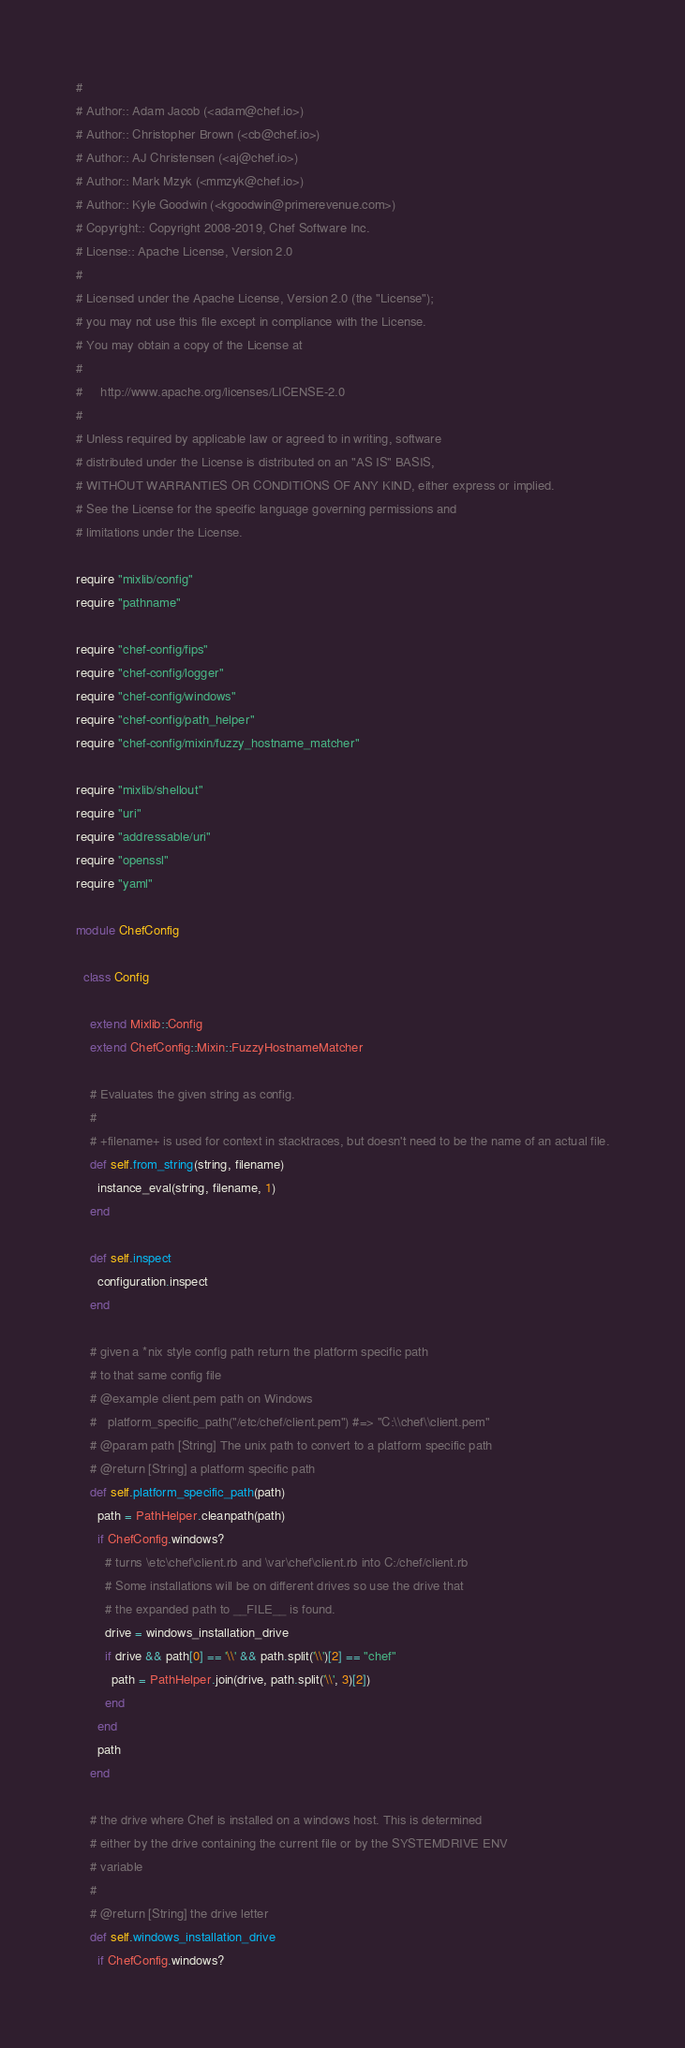Convert code to text. <code><loc_0><loc_0><loc_500><loc_500><_Ruby_>#
# Author:: Adam Jacob (<adam@chef.io>)
# Author:: Christopher Brown (<cb@chef.io>)
# Author:: AJ Christensen (<aj@chef.io>)
# Author:: Mark Mzyk (<mmzyk@chef.io>)
# Author:: Kyle Goodwin (<kgoodwin@primerevenue.com>)
# Copyright:: Copyright 2008-2019, Chef Software Inc.
# License:: Apache License, Version 2.0
#
# Licensed under the Apache License, Version 2.0 (the "License");
# you may not use this file except in compliance with the License.
# You may obtain a copy of the License at
#
#     http://www.apache.org/licenses/LICENSE-2.0
#
# Unless required by applicable law or agreed to in writing, software
# distributed under the License is distributed on an "AS IS" BASIS,
# WITHOUT WARRANTIES OR CONDITIONS OF ANY KIND, either express or implied.
# See the License for the specific language governing permissions and
# limitations under the License.

require "mixlib/config"
require "pathname"

require "chef-config/fips"
require "chef-config/logger"
require "chef-config/windows"
require "chef-config/path_helper"
require "chef-config/mixin/fuzzy_hostname_matcher"

require "mixlib/shellout"
require "uri"
require "addressable/uri"
require "openssl"
require "yaml"

module ChefConfig

  class Config

    extend Mixlib::Config
    extend ChefConfig::Mixin::FuzzyHostnameMatcher

    # Evaluates the given string as config.
    #
    # +filename+ is used for context in stacktraces, but doesn't need to be the name of an actual file.
    def self.from_string(string, filename)
      instance_eval(string, filename, 1)
    end

    def self.inspect
      configuration.inspect
    end

    # given a *nix style config path return the platform specific path
    # to that same config file
    # @example client.pem path on Windows
    #   platform_specific_path("/etc/chef/client.pem") #=> "C:\\chef\\client.pem"
    # @param path [String] The unix path to convert to a platform specific path
    # @return [String] a platform specific path
    def self.platform_specific_path(path)
      path = PathHelper.cleanpath(path)
      if ChefConfig.windows?
        # turns \etc\chef\client.rb and \var\chef\client.rb into C:/chef/client.rb
        # Some installations will be on different drives so use the drive that
        # the expanded path to __FILE__ is found.
        drive = windows_installation_drive
        if drive && path[0] == '\\' && path.split('\\')[2] == "chef"
          path = PathHelper.join(drive, path.split('\\', 3)[2])
        end
      end
      path
    end

    # the drive where Chef is installed on a windows host. This is determined
    # either by the drive containing the current file or by the SYSTEMDRIVE ENV
    # variable
    #
    # @return [String] the drive letter
    def self.windows_installation_drive
      if ChefConfig.windows?</code> 